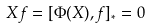Convert formula to latex. <formula><loc_0><loc_0><loc_500><loc_500>X f = [ \Phi ( X ) , f ] _ { * } = 0</formula> 